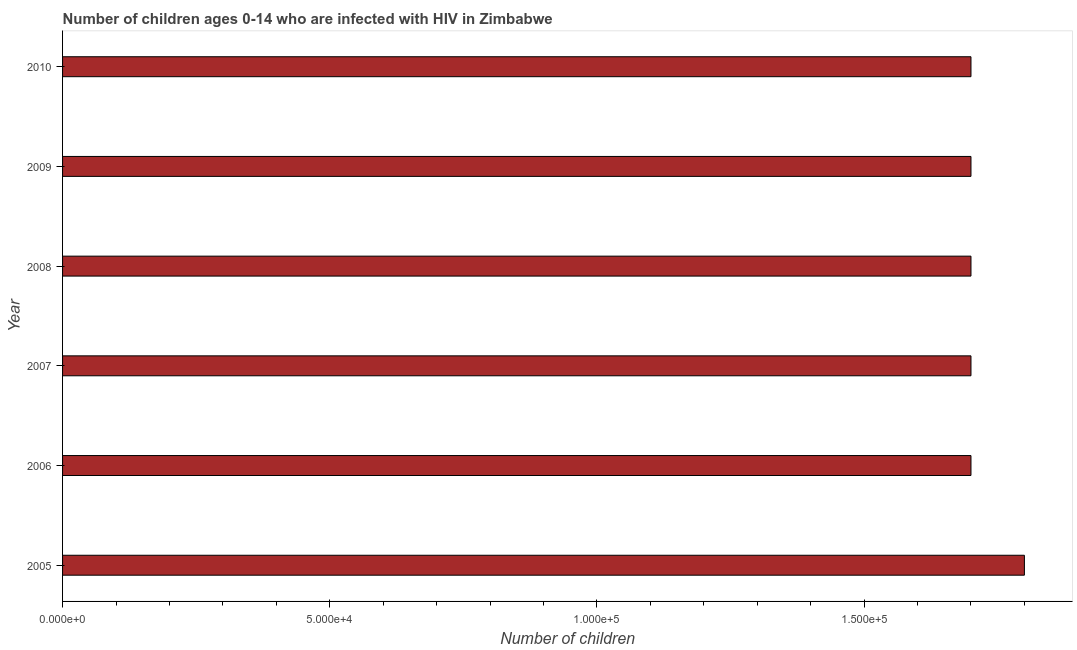What is the title of the graph?
Give a very brief answer. Number of children ages 0-14 who are infected with HIV in Zimbabwe. What is the label or title of the X-axis?
Keep it short and to the point. Number of children. What is the label or title of the Y-axis?
Ensure brevity in your answer.  Year. What is the number of children living with hiv in 2007?
Provide a succinct answer. 1.70e+05. Across all years, what is the minimum number of children living with hiv?
Ensure brevity in your answer.  1.70e+05. In which year was the number of children living with hiv minimum?
Make the answer very short. 2006. What is the sum of the number of children living with hiv?
Your response must be concise. 1.03e+06. What is the difference between the number of children living with hiv in 2006 and 2009?
Ensure brevity in your answer.  0. What is the average number of children living with hiv per year?
Your answer should be compact. 1.72e+05. Do a majority of the years between 2006 and 2007 (inclusive) have number of children living with hiv greater than 80000 ?
Keep it short and to the point. Yes. Is the number of children living with hiv in 2005 less than that in 2007?
Provide a short and direct response. No. What is the difference between the highest and the second highest number of children living with hiv?
Give a very brief answer. 10000. What is the difference between the highest and the lowest number of children living with hiv?
Keep it short and to the point. 10000. What is the difference between two consecutive major ticks on the X-axis?
Make the answer very short. 5.00e+04. Are the values on the major ticks of X-axis written in scientific E-notation?
Provide a short and direct response. Yes. What is the Number of children in 2009?
Provide a short and direct response. 1.70e+05. What is the Number of children in 2010?
Provide a short and direct response. 1.70e+05. What is the difference between the Number of children in 2005 and 2007?
Your response must be concise. 10000. What is the difference between the Number of children in 2005 and 2008?
Provide a short and direct response. 10000. What is the difference between the Number of children in 2005 and 2009?
Your answer should be compact. 10000. What is the difference between the Number of children in 2006 and 2007?
Your response must be concise. 0. What is the difference between the Number of children in 2006 and 2009?
Provide a short and direct response. 0. What is the difference between the Number of children in 2007 and 2008?
Your response must be concise. 0. What is the difference between the Number of children in 2007 and 2009?
Make the answer very short. 0. What is the difference between the Number of children in 2007 and 2010?
Keep it short and to the point. 0. What is the difference between the Number of children in 2008 and 2010?
Ensure brevity in your answer.  0. What is the ratio of the Number of children in 2005 to that in 2006?
Provide a succinct answer. 1.06. What is the ratio of the Number of children in 2005 to that in 2007?
Keep it short and to the point. 1.06. What is the ratio of the Number of children in 2005 to that in 2008?
Your answer should be very brief. 1.06. What is the ratio of the Number of children in 2005 to that in 2009?
Offer a very short reply. 1.06. What is the ratio of the Number of children in 2005 to that in 2010?
Offer a terse response. 1.06. What is the ratio of the Number of children in 2006 to that in 2007?
Offer a terse response. 1. What is the ratio of the Number of children in 2006 to that in 2008?
Offer a terse response. 1. What is the ratio of the Number of children in 2006 to that in 2009?
Offer a very short reply. 1. What is the ratio of the Number of children in 2007 to that in 2008?
Offer a terse response. 1. What is the ratio of the Number of children in 2007 to that in 2009?
Offer a very short reply. 1. What is the ratio of the Number of children in 2009 to that in 2010?
Your response must be concise. 1. 